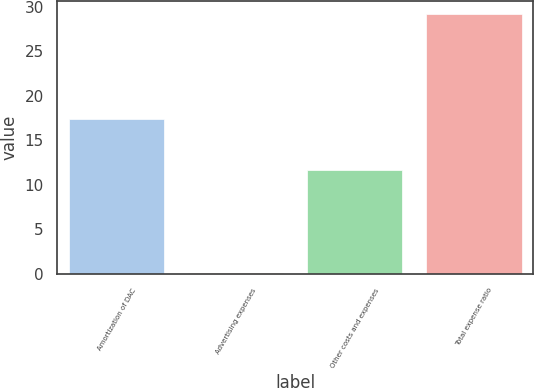<chart> <loc_0><loc_0><loc_500><loc_500><bar_chart><fcel>Amortization of DAC<fcel>Advertising expenses<fcel>Other costs and expenses<fcel>Total expense ratio<nl><fcel>17.4<fcel>0.1<fcel>11.7<fcel>29.2<nl></chart> 